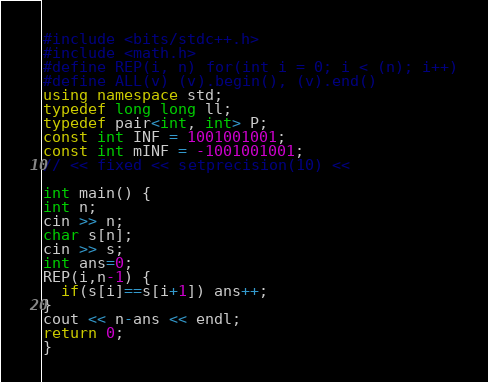<code> <loc_0><loc_0><loc_500><loc_500><_C++_>
#include <bits/stdc++.h>
#include <math.h>
#define REP(i, n) for(int i = 0; i < (n); i++)
#define ALL(v) (v).begin(), (v).end()
using namespace std;
typedef long long ll;
typedef pair<int, int> P;
const int INF = 1001001001;
const int mINF = -1001001001;
// << fixed << setprecision(10) <<

int main() {
int n;
cin >> n;
char s[n];
cin >> s;
int ans=0;
REP(i,n-1) {
  if(s[i]==s[i+1]) ans++;
}
cout << n-ans << endl;
return 0;
}
</code> 